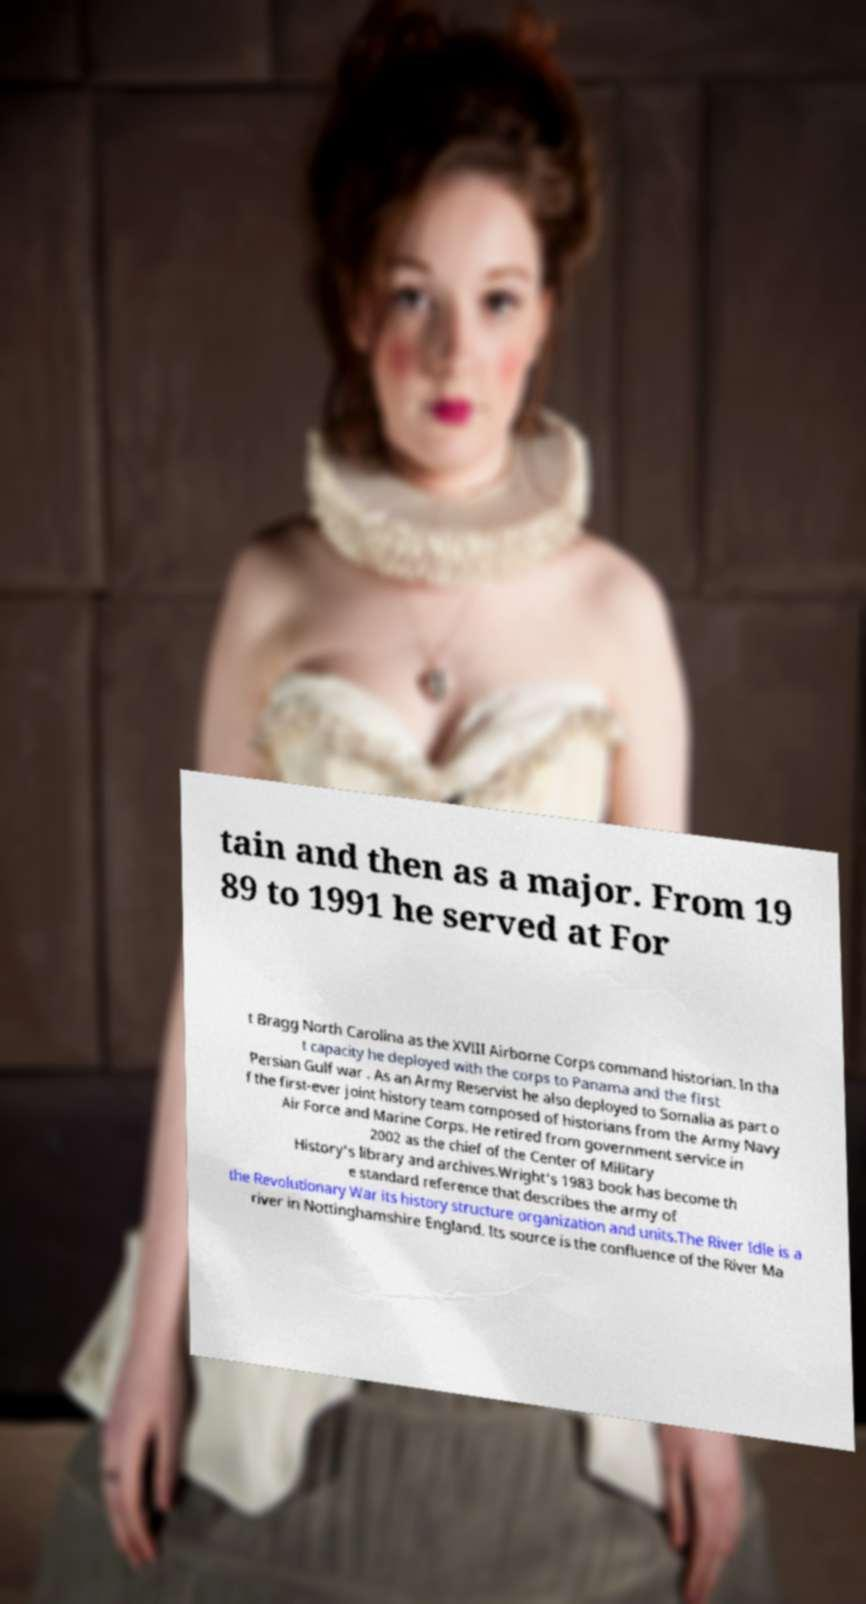Please read and relay the text visible in this image. What does it say? tain and then as a major. From 19 89 to 1991 he served at For t Bragg North Carolina as the XVIII Airborne Corps command historian. In tha t capacity he deployed with the corps to Panama and the first Persian Gulf war . As an Army Reservist he also deployed to Somalia as part o f the first-ever joint history team composed of historians from the Army Navy Air Force and Marine Corps. He retired from government service in 2002 as the chief of the Center of Military History's library and archives.Wright's 1983 book has become th e standard reference that describes the army of the Revolutionary War its history structure organization and units.The River Idle is a river in Nottinghamshire England. Its source is the confluence of the River Ma 